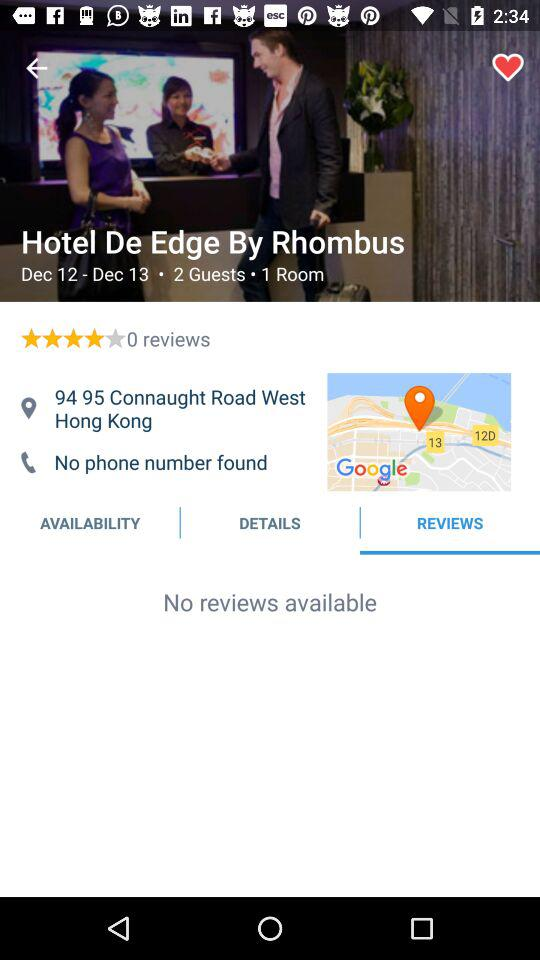How many reviews does the hotel have?
Answer the question using a single word or phrase. 0 